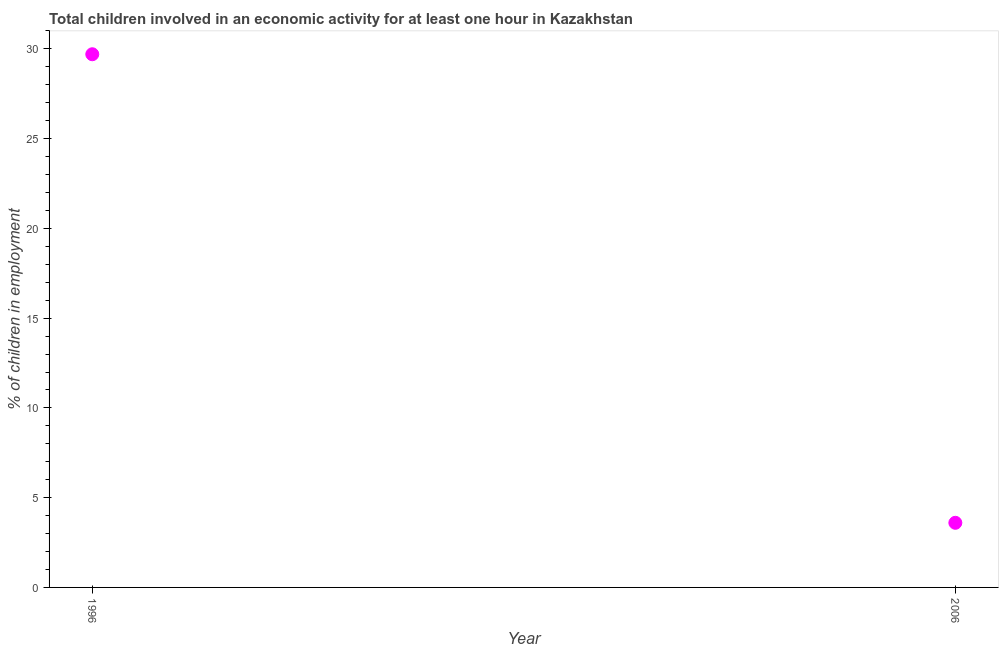Across all years, what is the maximum percentage of children in employment?
Give a very brief answer. 29.7. Across all years, what is the minimum percentage of children in employment?
Make the answer very short. 3.6. In which year was the percentage of children in employment minimum?
Give a very brief answer. 2006. What is the sum of the percentage of children in employment?
Offer a very short reply. 33.3. What is the difference between the percentage of children in employment in 1996 and 2006?
Offer a terse response. 26.1. What is the average percentage of children in employment per year?
Offer a very short reply. 16.65. What is the median percentage of children in employment?
Make the answer very short. 16.65. In how many years, is the percentage of children in employment greater than 28 %?
Give a very brief answer. 1. Do a majority of the years between 2006 and 1996 (inclusive) have percentage of children in employment greater than 5 %?
Make the answer very short. No. What is the ratio of the percentage of children in employment in 1996 to that in 2006?
Provide a succinct answer. 8.25. Is the percentage of children in employment in 1996 less than that in 2006?
Offer a terse response. No. In how many years, is the percentage of children in employment greater than the average percentage of children in employment taken over all years?
Offer a terse response. 1. How many dotlines are there?
Your answer should be compact. 1. How many years are there in the graph?
Give a very brief answer. 2. What is the difference between two consecutive major ticks on the Y-axis?
Your response must be concise. 5. Does the graph contain any zero values?
Give a very brief answer. No. Does the graph contain grids?
Offer a very short reply. No. What is the title of the graph?
Provide a succinct answer. Total children involved in an economic activity for at least one hour in Kazakhstan. What is the label or title of the Y-axis?
Offer a terse response. % of children in employment. What is the % of children in employment in 1996?
Keep it short and to the point. 29.7. What is the % of children in employment in 2006?
Make the answer very short. 3.6. What is the difference between the % of children in employment in 1996 and 2006?
Your answer should be compact. 26.1. What is the ratio of the % of children in employment in 1996 to that in 2006?
Offer a very short reply. 8.25. 